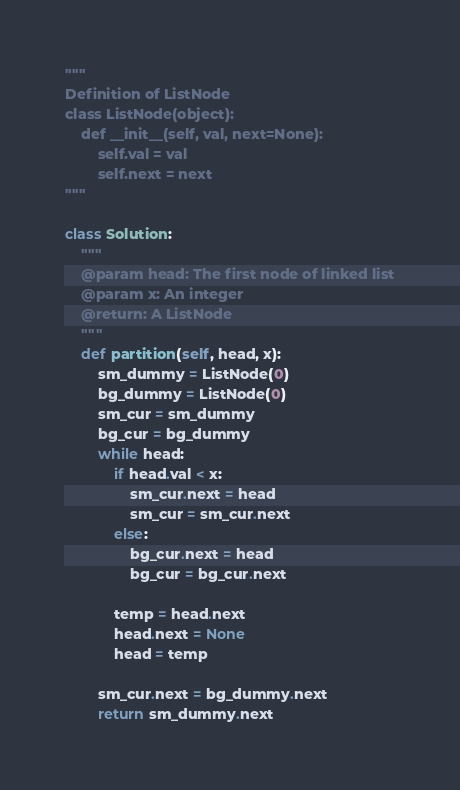Convert code to text. <code><loc_0><loc_0><loc_500><loc_500><_Python_>"""
Definition of ListNode
class ListNode(object):
    def __init__(self, val, next=None):
        self.val = val
        self.next = next
"""

class Solution:
    """
    @param head: The first node of linked list
    @param x: An integer
    @return: A ListNode
    """
    def partition(self, head, x):
        sm_dummy = ListNode(0)
        bg_dummy = ListNode(0)
        sm_cur = sm_dummy
        bg_cur = bg_dummy
        while head:
            if head.val < x:
                sm_cur.next = head
                sm_cur = sm_cur.next
            else:
                bg_cur.next = head
                bg_cur = bg_cur.next

            temp = head.next
            head.next = None
            head = temp

        sm_cur.next = bg_dummy.next
        return sm_dummy.next</code> 